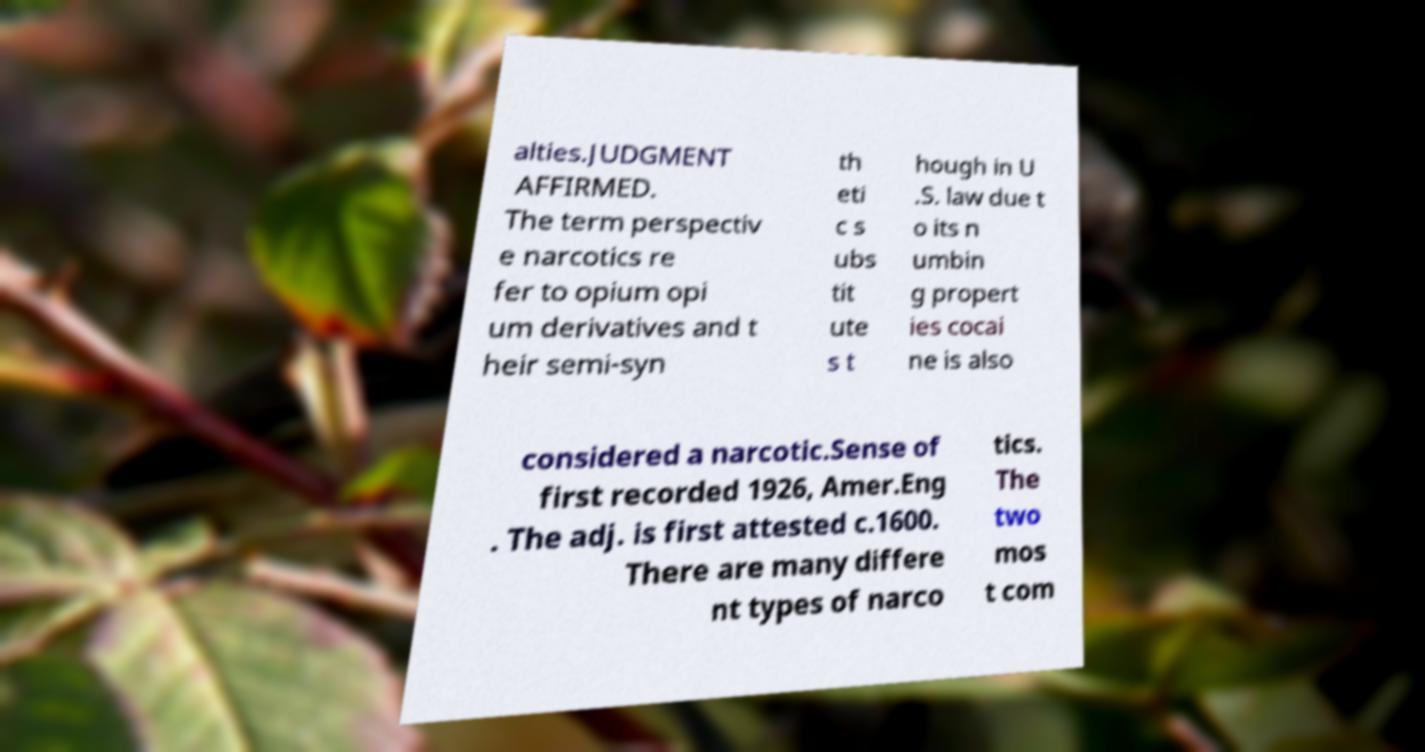What messages or text are displayed in this image? I need them in a readable, typed format. alties.JUDGMENT AFFIRMED. The term perspectiv e narcotics re fer to opium opi um derivatives and t heir semi-syn th eti c s ubs tit ute s t hough in U .S. law due t o its n umbin g propert ies cocai ne is also considered a narcotic.Sense of first recorded 1926, Amer.Eng . The adj. is first attested c.1600. There are many differe nt types of narco tics. The two mos t com 